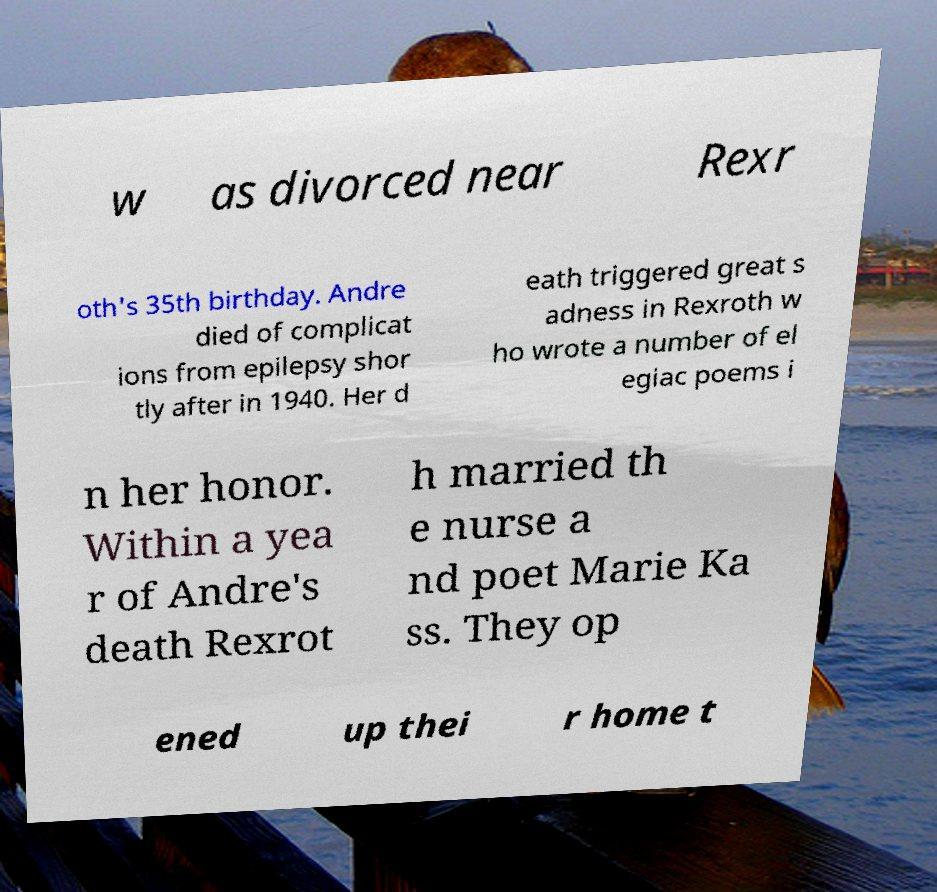For documentation purposes, I need the text within this image transcribed. Could you provide that? w as divorced near Rexr oth's 35th birthday. Andre died of complicat ions from epilepsy shor tly after in 1940. Her d eath triggered great s adness in Rexroth w ho wrote a number of el egiac poems i n her honor. Within a yea r of Andre's death Rexrot h married th e nurse a nd poet Marie Ka ss. They op ened up thei r home t 